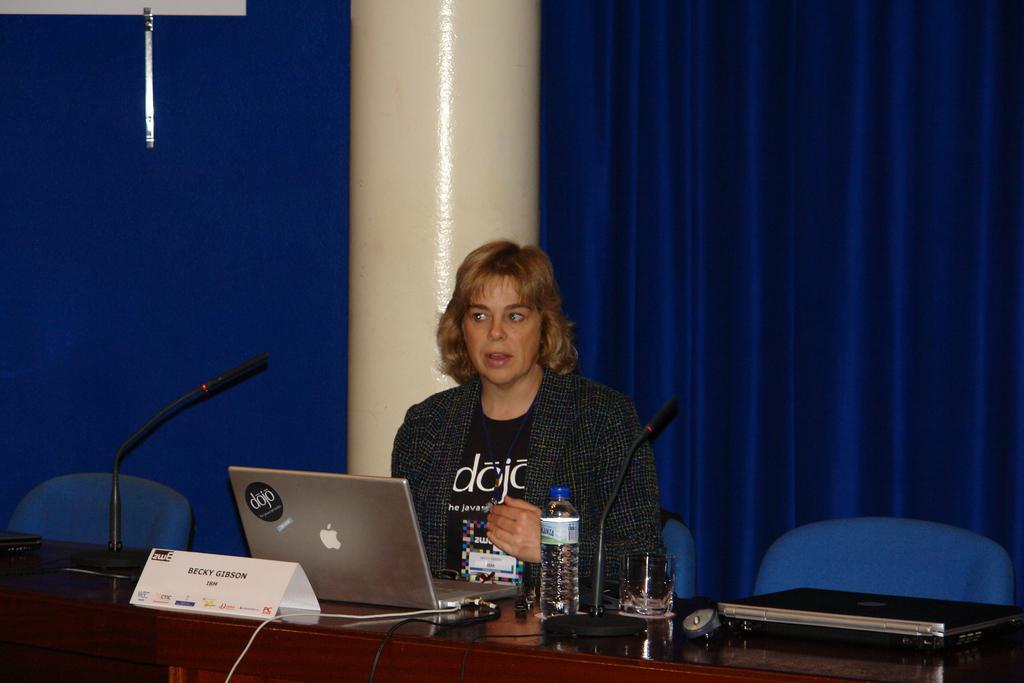How would you summarize this image in a sentence or two? In this image we can see a woman is sitting on blue chair. In front of her table is there. On table laptops, glass, bottle, mics and name plate are there. Background of the image blue color curtain and white color pillar is there. 